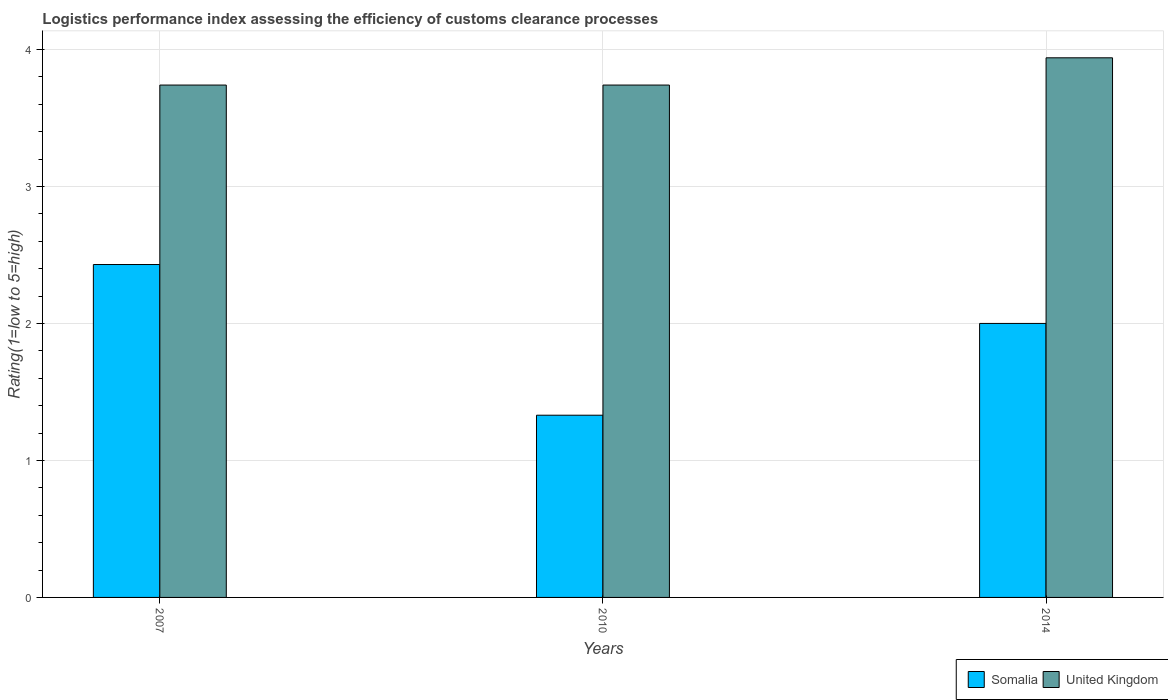How many different coloured bars are there?
Your response must be concise. 2. How many groups of bars are there?
Give a very brief answer. 3. Are the number of bars per tick equal to the number of legend labels?
Offer a very short reply. Yes. How many bars are there on the 2nd tick from the left?
Provide a short and direct response. 2. What is the Logistic performance index in United Kingdom in 2014?
Offer a very short reply. 3.94. Across all years, what is the maximum Logistic performance index in Somalia?
Ensure brevity in your answer.  2.43. Across all years, what is the minimum Logistic performance index in United Kingdom?
Make the answer very short. 3.74. In which year was the Logistic performance index in United Kingdom minimum?
Provide a short and direct response. 2007. What is the total Logistic performance index in United Kingdom in the graph?
Offer a very short reply. 11.42. What is the difference between the Logistic performance index in United Kingdom in 2010 and the Logistic performance index in Somalia in 2014?
Your answer should be very brief. 1.74. What is the average Logistic performance index in Somalia per year?
Offer a very short reply. 1.92. In the year 2007, what is the difference between the Logistic performance index in United Kingdom and Logistic performance index in Somalia?
Keep it short and to the point. 1.31. What is the ratio of the Logistic performance index in United Kingdom in 2010 to that in 2014?
Make the answer very short. 0.95. What is the difference between the highest and the second highest Logistic performance index in Somalia?
Make the answer very short. 0.43. What is the difference between the highest and the lowest Logistic performance index in United Kingdom?
Offer a very short reply. 0.2. Is the sum of the Logistic performance index in United Kingdom in 2007 and 2010 greater than the maximum Logistic performance index in Somalia across all years?
Ensure brevity in your answer.  Yes. What does the 2nd bar from the left in 2014 represents?
Ensure brevity in your answer.  United Kingdom. What does the 2nd bar from the right in 2007 represents?
Ensure brevity in your answer.  Somalia. How many years are there in the graph?
Make the answer very short. 3. Are the values on the major ticks of Y-axis written in scientific E-notation?
Give a very brief answer. No. How are the legend labels stacked?
Keep it short and to the point. Horizontal. What is the title of the graph?
Offer a very short reply. Logistics performance index assessing the efficiency of customs clearance processes. Does "Netherlands" appear as one of the legend labels in the graph?
Make the answer very short. No. What is the label or title of the X-axis?
Make the answer very short. Years. What is the label or title of the Y-axis?
Keep it short and to the point. Rating(1=low to 5=high). What is the Rating(1=low to 5=high) in Somalia in 2007?
Make the answer very short. 2.43. What is the Rating(1=low to 5=high) of United Kingdom in 2007?
Your answer should be very brief. 3.74. What is the Rating(1=low to 5=high) in Somalia in 2010?
Keep it short and to the point. 1.33. What is the Rating(1=low to 5=high) in United Kingdom in 2010?
Provide a succinct answer. 3.74. What is the Rating(1=low to 5=high) of United Kingdom in 2014?
Ensure brevity in your answer.  3.94. Across all years, what is the maximum Rating(1=low to 5=high) of Somalia?
Your response must be concise. 2.43. Across all years, what is the maximum Rating(1=low to 5=high) in United Kingdom?
Ensure brevity in your answer.  3.94. Across all years, what is the minimum Rating(1=low to 5=high) of Somalia?
Provide a succinct answer. 1.33. Across all years, what is the minimum Rating(1=low to 5=high) in United Kingdom?
Make the answer very short. 3.74. What is the total Rating(1=low to 5=high) in Somalia in the graph?
Your response must be concise. 5.76. What is the total Rating(1=low to 5=high) in United Kingdom in the graph?
Provide a succinct answer. 11.42. What is the difference between the Rating(1=low to 5=high) in Somalia in 2007 and that in 2014?
Your answer should be compact. 0.43. What is the difference between the Rating(1=low to 5=high) in United Kingdom in 2007 and that in 2014?
Make the answer very short. -0.2. What is the difference between the Rating(1=low to 5=high) of Somalia in 2010 and that in 2014?
Your answer should be very brief. -0.67. What is the difference between the Rating(1=low to 5=high) of United Kingdom in 2010 and that in 2014?
Your response must be concise. -0.2. What is the difference between the Rating(1=low to 5=high) of Somalia in 2007 and the Rating(1=low to 5=high) of United Kingdom in 2010?
Ensure brevity in your answer.  -1.31. What is the difference between the Rating(1=low to 5=high) of Somalia in 2007 and the Rating(1=low to 5=high) of United Kingdom in 2014?
Your answer should be compact. -1.51. What is the difference between the Rating(1=low to 5=high) in Somalia in 2010 and the Rating(1=low to 5=high) in United Kingdom in 2014?
Keep it short and to the point. -2.61. What is the average Rating(1=low to 5=high) of Somalia per year?
Your answer should be very brief. 1.92. What is the average Rating(1=low to 5=high) of United Kingdom per year?
Your answer should be compact. 3.81. In the year 2007, what is the difference between the Rating(1=low to 5=high) of Somalia and Rating(1=low to 5=high) of United Kingdom?
Your response must be concise. -1.31. In the year 2010, what is the difference between the Rating(1=low to 5=high) in Somalia and Rating(1=low to 5=high) in United Kingdom?
Make the answer very short. -2.41. In the year 2014, what is the difference between the Rating(1=low to 5=high) in Somalia and Rating(1=low to 5=high) in United Kingdom?
Ensure brevity in your answer.  -1.94. What is the ratio of the Rating(1=low to 5=high) of Somalia in 2007 to that in 2010?
Provide a short and direct response. 1.83. What is the ratio of the Rating(1=low to 5=high) of United Kingdom in 2007 to that in 2010?
Give a very brief answer. 1. What is the ratio of the Rating(1=low to 5=high) in Somalia in 2007 to that in 2014?
Your answer should be very brief. 1.22. What is the ratio of the Rating(1=low to 5=high) of United Kingdom in 2007 to that in 2014?
Make the answer very short. 0.95. What is the ratio of the Rating(1=low to 5=high) in Somalia in 2010 to that in 2014?
Your answer should be very brief. 0.67. What is the ratio of the Rating(1=low to 5=high) of United Kingdom in 2010 to that in 2014?
Make the answer very short. 0.95. What is the difference between the highest and the second highest Rating(1=low to 5=high) in Somalia?
Provide a short and direct response. 0.43. What is the difference between the highest and the second highest Rating(1=low to 5=high) in United Kingdom?
Provide a succinct answer. 0.2. What is the difference between the highest and the lowest Rating(1=low to 5=high) of United Kingdom?
Give a very brief answer. 0.2. 